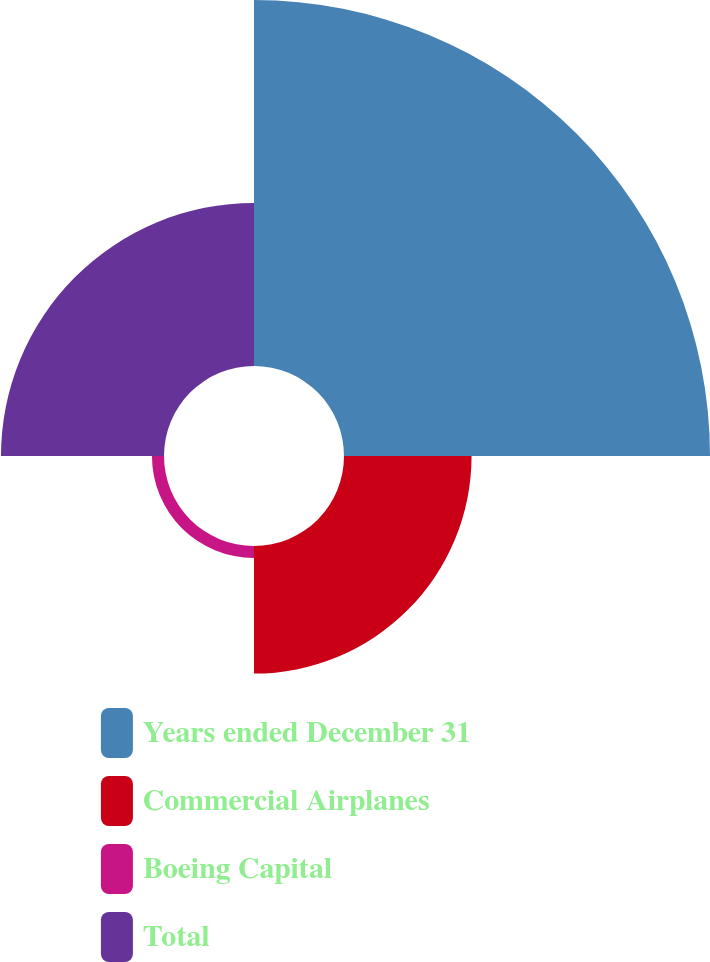Convert chart. <chart><loc_0><loc_0><loc_500><loc_500><pie_chart><fcel>Years ended December 31<fcel>Commercial Airplanes<fcel>Boeing Capital<fcel>Total<nl><fcel>54.74%<fcel>19.08%<fcel>1.8%<fcel>24.38%<nl></chart> 